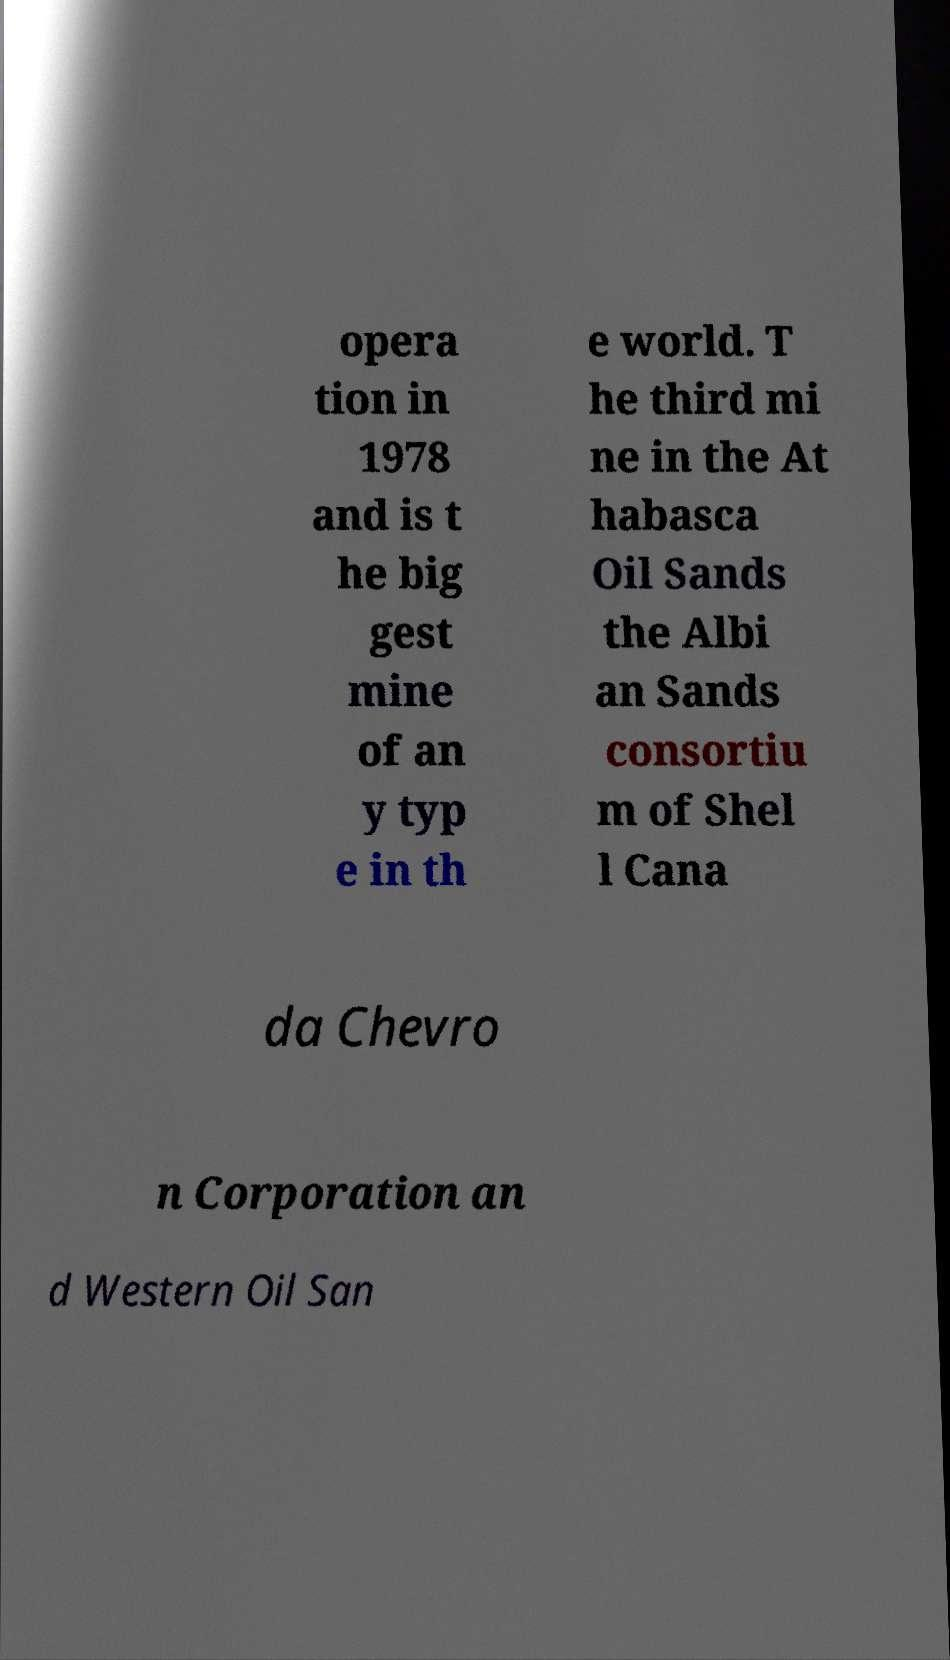I need the written content from this picture converted into text. Can you do that? opera tion in 1978 and is t he big gest mine of an y typ e in th e world. T he third mi ne in the At habasca Oil Sands the Albi an Sands consortiu m of Shel l Cana da Chevro n Corporation an d Western Oil San 